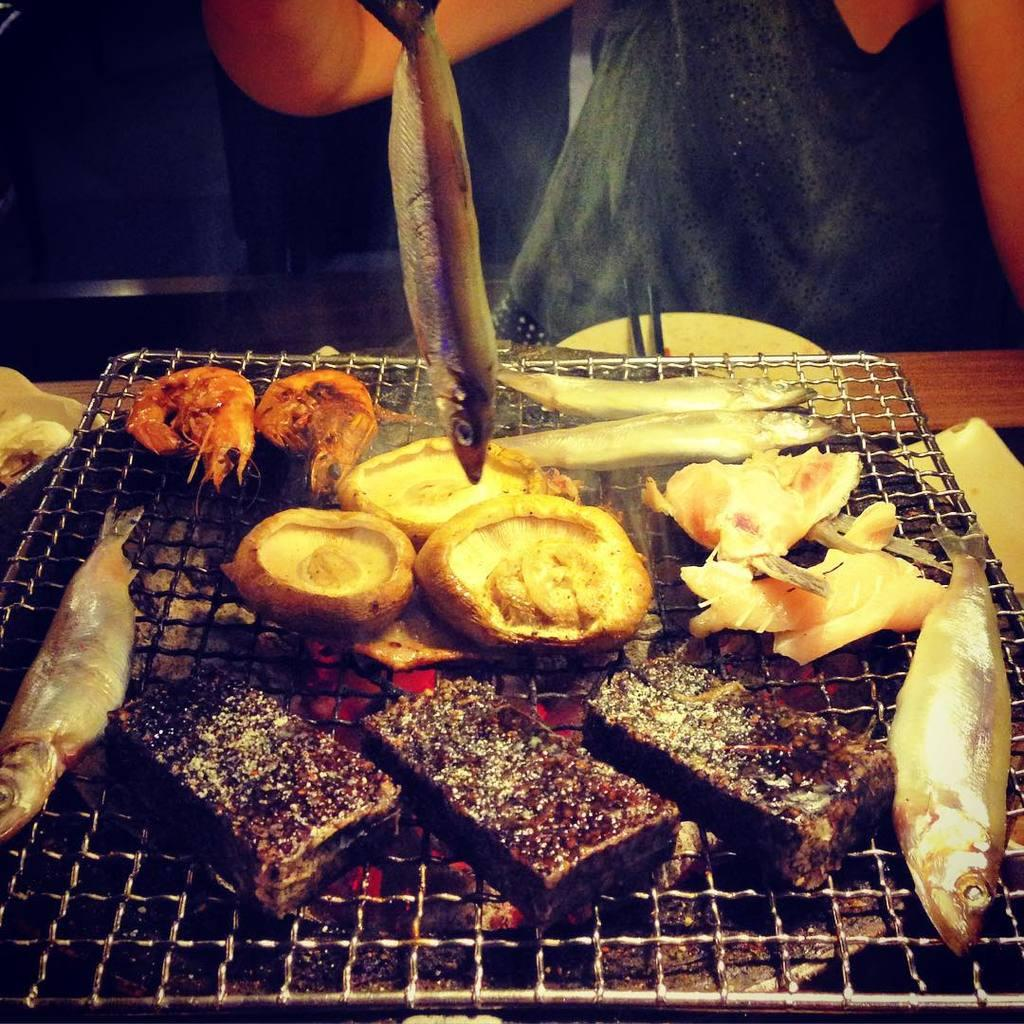What type of meat is present in the image? There are mutton pieces in the image. What other seafood can be seen in the image? There are crabs in the image. What is the cooking method for the food items in the image? The food items are placed on a barbecue grill. What is the price of the spark in the image? There is no spark present in the image, and therefore no price can be determined. Are there any berries visible in the image? There are no berries present in the image. 